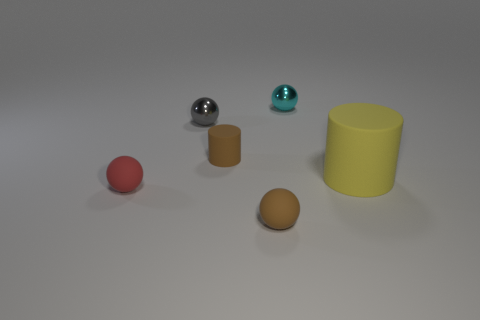Add 1 large rubber balls. How many objects exist? 7 Subtract all cylinders. How many objects are left? 4 Subtract all gray spheres. Subtract all small red rubber things. How many objects are left? 4 Add 4 small matte things. How many small matte things are left? 7 Add 4 small brown things. How many small brown things exist? 6 Subtract 1 brown cylinders. How many objects are left? 5 